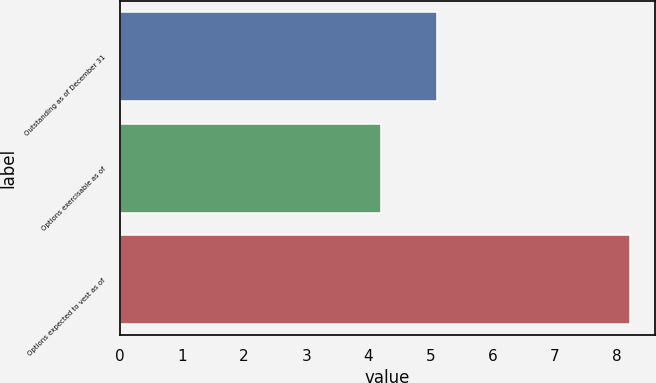Convert chart to OTSL. <chart><loc_0><loc_0><loc_500><loc_500><bar_chart><fcel>Outstanding as of December 31<fcel>Options exercisable as of<fcel>Options expected to vest as of<nl><fcel>5.1<fcel>4.2<fcel>8.2<nl></chart> 